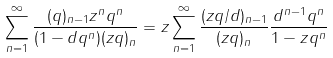<formula> <loc_0><loc_0><loc_500><loc_500>\sum _ { n = 1 } ^ { \infty } \frac { ( q ) _ { n - 1 } z ^ { n } q ^ { n } } { ( 1 - d q ^ { n } ) ( z q ) _ { n } } & = z \sum _ { n = 1 } ^ { \infty } \frac { ( z q / d ) _ { n - 1 } } { ( z q ) _ { n } } \frac { d ^ { n - 1 } q ^ { n } } { 1 - z q ^ { n } }</formula> 